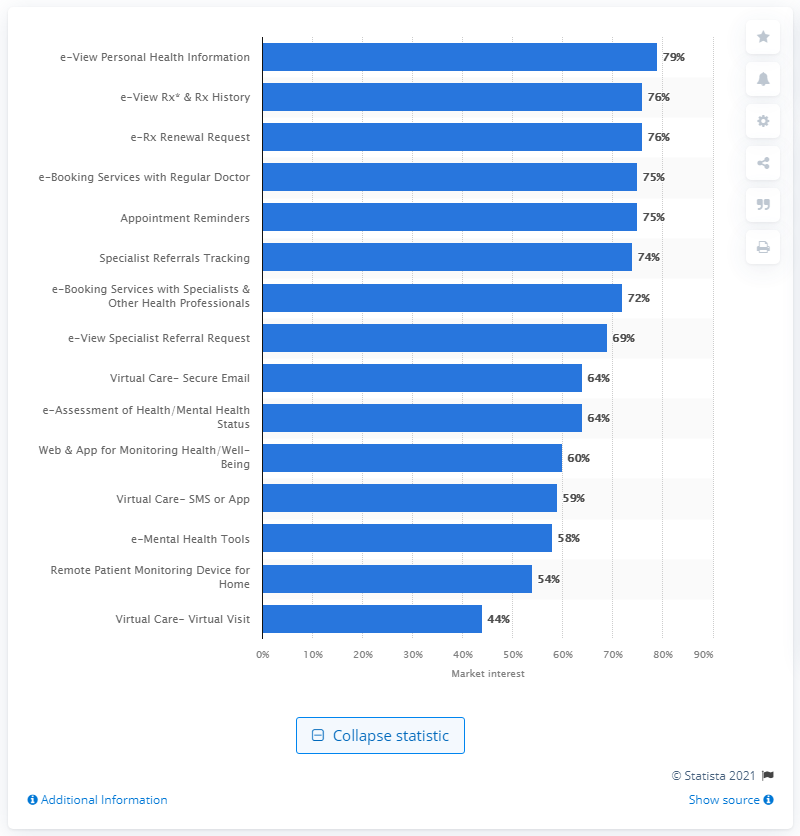List a handful of essential elements in this visual. A majority of adult Canadians, which was approximately 79%, expressed interest in utilizing e-View Personal Health Information as a means of accessing their health information for digital health services. 